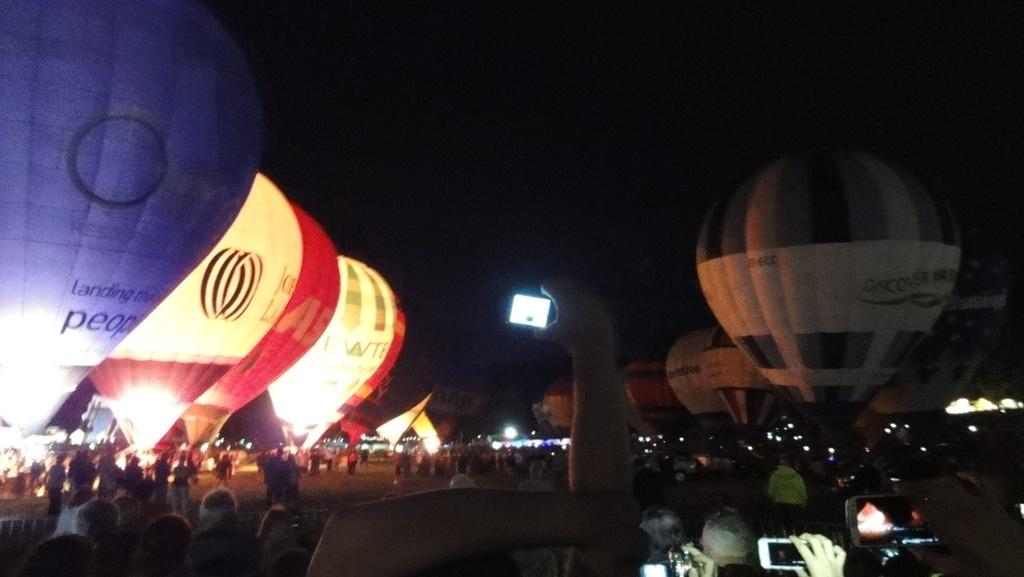What is the main subject of the image? The main subject of the image is many parachutes. What are the people at the bottom of the image doing? The people are standing at the bottom of the image. What objects are the people holding? The people are holding mobiles. What is visible at the top of the image? The sky is visible at the top of the image. What type of bead is being used to measure the current in the image? There is no bead or current present in the image; it features parachutes and people holding mobiles. 